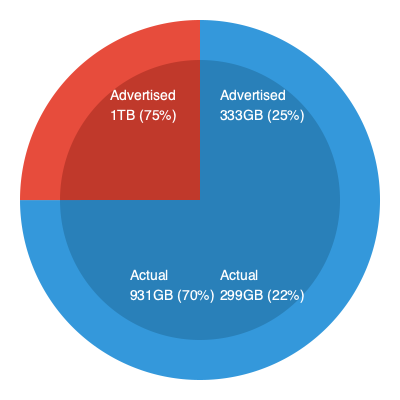A popular cloud storage service advertises 1TB (1000GB) of storage space. The pie chart shows the advertised capacity compared to the actual measured capacity. What percentage of the advertised storage is actually available to users, and what could explain this discrepancy? To solve this problem, we need to analyze the information provided in the pie chart:

1. Advertised storage:
   - 1TB (1000GB) total
   - 75% of the outer circle represents 1TB
   - 25% of the outer circle represents 333GB

2. Actual storage:
   - 70% of the inner circle represents 931GB
   - 22% of the inner circle represents 299GB
   - Total actual storage: 931GB + 299GB = 1230GB

3. Calculate the percentage of advertised storage actually available:
   $\frac{\text{Actual storage}}{\text{Advertised storage}} \times 100\% = \frac{1230\text{GB}}{1333\text{GB}} \times 100\% \approx 92.27\%$

4. Possible explanations for the discrepancy:
   a) The cloud service provider uses base-2 (binary) units instead of base-10 units:
      1TB in base-2 = 1024GB, not 1000GB
   b) Some storage space is reserved for system use, metadata, and redundancy
   c) The provider may be using aggressive data compression techniques
   d) Marketing strategies often round up numbers for simplicity

The actual available storage is about 92.27% of the advertised amount, which is closer to the true capacity of 1TB in base-2 units (1024GB).
Answer: 92.27%; base-2 vs. base-10 units, system overhead, compression, marketing rounding 